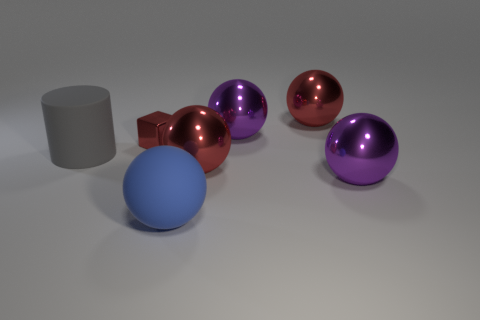Does the tiny metal cube have the same color as the rubber object in front of the large cylinder? No, the tiny metal cube has a distinct reddish-brown hue that is reminiscent of copper, while the rubber object in front of the large cylinder sports a light blue coloration, providing a pleasing contrast between the two items. 